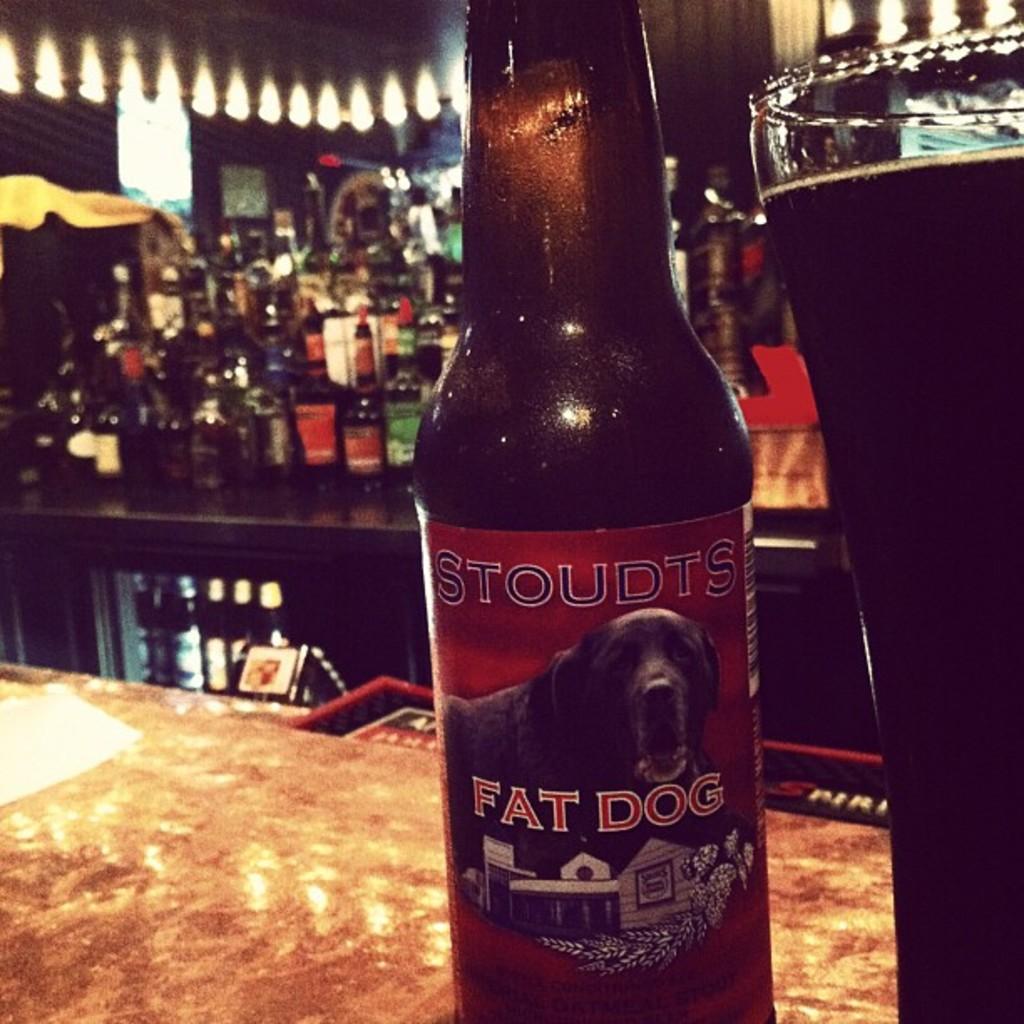Who makes the,"fat dog" flavored beer?
Your answer should be very brief. Stoudts. What type of animal is pictured on the bottle?
Your answer should be compact. Dog. 